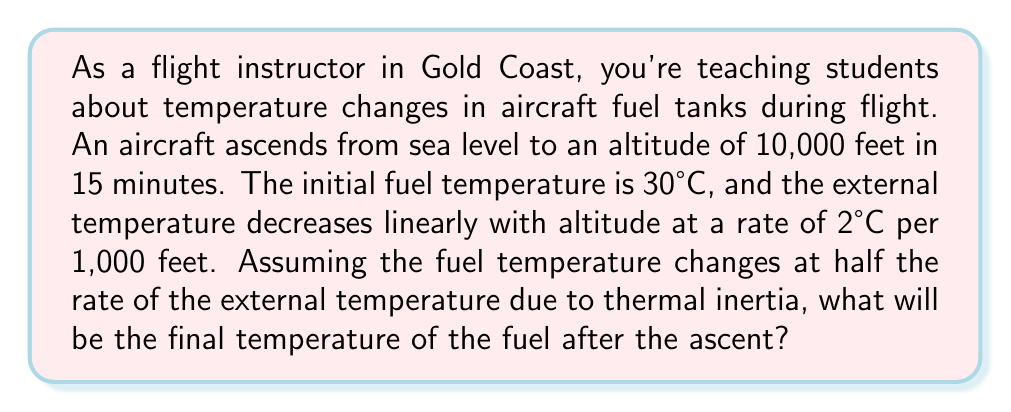Can you solve this math problem? Let's approach this step-by-step:

1) First, we need to calculate the total change in external temperature:
   - Altitude change = 10,000 feet
   - Temperature change rate = 2°C per 1,000 feet
   - Total external temperature change = $10,000 \div 1,000 \times 2 = 20°C$

2) The external temperature at 10,000 feet will be:
   $30°C - 20°C = 10°C$

3) Now, we consider that the fuel temperature changes at half the rate of the external temperature:
   - Fuel temperature change rate = $\frac{1}{2} \times 2°C$ per 1,000 feet = 1°C per 1,000 feet

4) Calculate the total change in fuel temperature:
   $10,000 \div 1,000 \times 1 = 10°C$

5) Therefore, the final fuel temperature will be:
   $30°C - 10°C = 20°C$

The heat equation for this scenario, assuming a simplified one-dimensional model, would be:

$$\frac{\partial T}{\partial t} = \alpha \frac{\partial^2 T}{\partial x^2}$$

Where $T$ is temperature, $t$ is time, $x$ is position in the tank, and $\alpha$ is the thermal diffusivity of the fuel. However, solving this equation would require more complex boundary conditions and numerical methods, which are beyond the scope of this simplified problem.
Answer: 20°C 